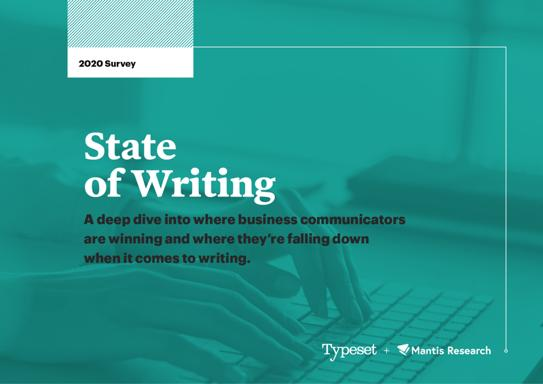What is the focus of the report mentioned in the image? The report titled '2020 Survey State of Writing' primarily investigates the performance of business communicators, identifying their strengths and pinpointing challenges in their writing practices. It seeks to offer insights and potentially recommend improvements to enhance effectiveness in business communication. 